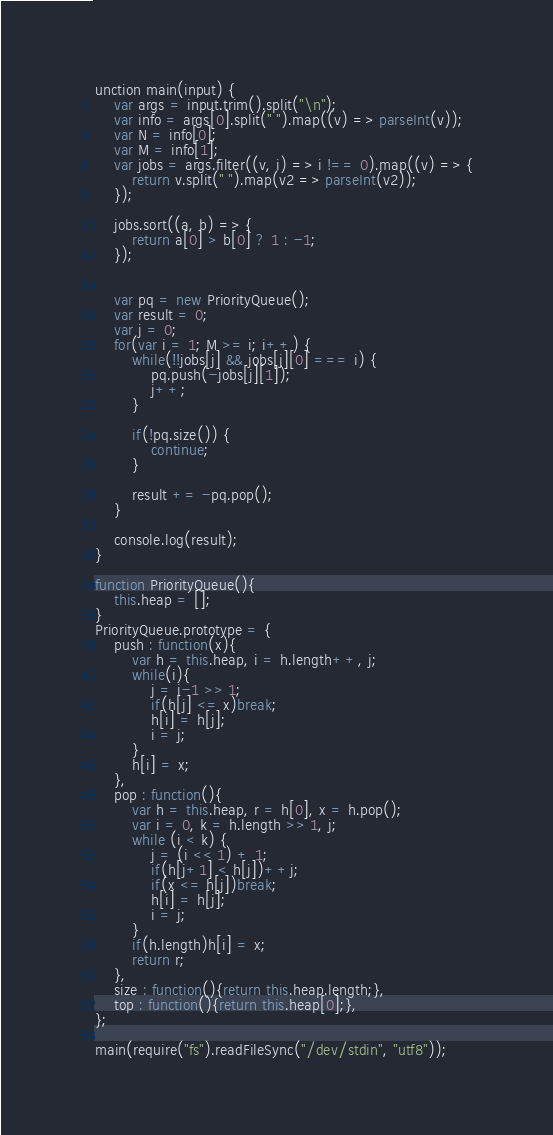<code> <loc_0><loc_0><loc_500><loc_500><_JavaScript_>unction main(input) {
    var args = input.trim().split("\n");
    var info = args[0].split(" ").map((v) => parseInt(v));
    var N = info[0];
    var M = info[1];
    var jobs = args.filter((v, i) => i !== 0).map((v) => {
        return v.split(" ").map(v2 => parseInt(v2));
    });

    jobs.sort((a, b) => {
        return a[0] > b[0] ? 1 : -1;
    });


    var pq = new PriorityQueue();
    var result = 0;
    var j = 0;
    for(var i = 1; M >= i; i++) {
        while(!!jobs[j] && jobs[j][0] === i) {
            pq.push(-jobs[j][1]);
            j++;
        }

        if(!pq.size()) {
            continue;
        }

        result += -pq.pop();
    }

    console.log(result);
}

function PriorityQueue(){
    this.heap = [];
}
PriorityQueue.prototype = {
    push : function(x){
        var h = this.heap, i = h.length++, j;
        while(i){
            j = i-1 >> 1;
            if(h[j] <= x)break;
            h[i] = h[j];
            i = j;
        }
        h[i] = x;
    },
    pop : function(){
        var h = this.heap, r = h[0], x = h.pop();
        var i = 0, k = h.length >> 1, j;
        while (i < k) {
            j = (i << 1) + 1;
            if(h[j+1] < h[j])++j;
            if(x <= h[j])break;
            h[i] = h[j];
            i = j;
        }
        if(h.length)h[i] = x;
        return r;
    },
    size : function(){return this.heap.length;},
    top : function(){return this.heap[0];},
};

main(require("fs").readFileSync("/dev/stdin", "utf8"));</code> 